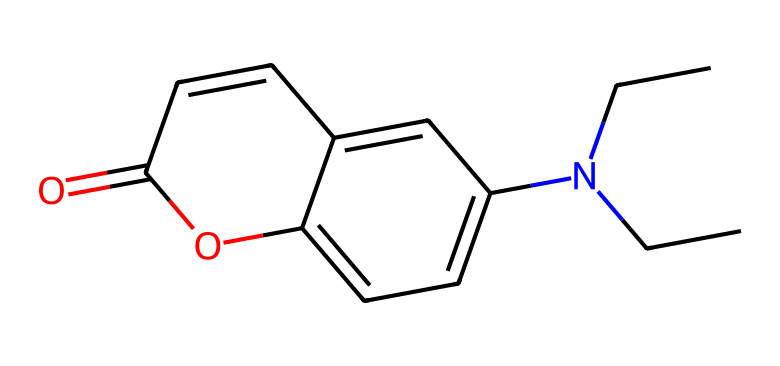What is the main functional group present in this chemical? By examining the structure, we can identify a carbonyl group (C=O) in the molecule. This is characterized by a carbon atom double-bonded to an oxygen atom.
Answer: carbonyl group How many nitrogen atoms are present in this compound? Looking at the SMILES representation, there is only one nitrogen atom present in the structure, as indicated by "N" in the molecule.
Answer: one What type of chemical is this compound categorized as? Given its light-activated properties indicated by the presence of a phenolic structure and the functional groups, this compound is classified as a photoreactive fluorescent compound.
Answer: photoreactive fluorescent compound What is the total number of aromatic rings in this chemical? The structure reveals two aromatic rings which can be observed within the cyclic components of the chemical's layout.
Answer: two Which substituent appears on the nitrogen atom? The nitrogen atom in this compound is bonded to two ethyl groups (due to "N(CC)CC"), indicating that it has diethyl substituents.
Answer: diethyl What is the role of the oxygen atom in the compound? The oxygen atoms are part of a phenolic group and a carbonyl group, contributing to the compound's capacity for photoreactivity and fluorescence.
Answer: photoreactivity and fluorescence 